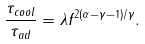<formula> <loc_0><loc_0><loc_500><loc_500>\frac { \tau _ { c o o l } } { \tau _ { a d } } = \lambda f ^ { 2 ( \alpha - \gamma - 1 ) / \gamma } .</formula> 